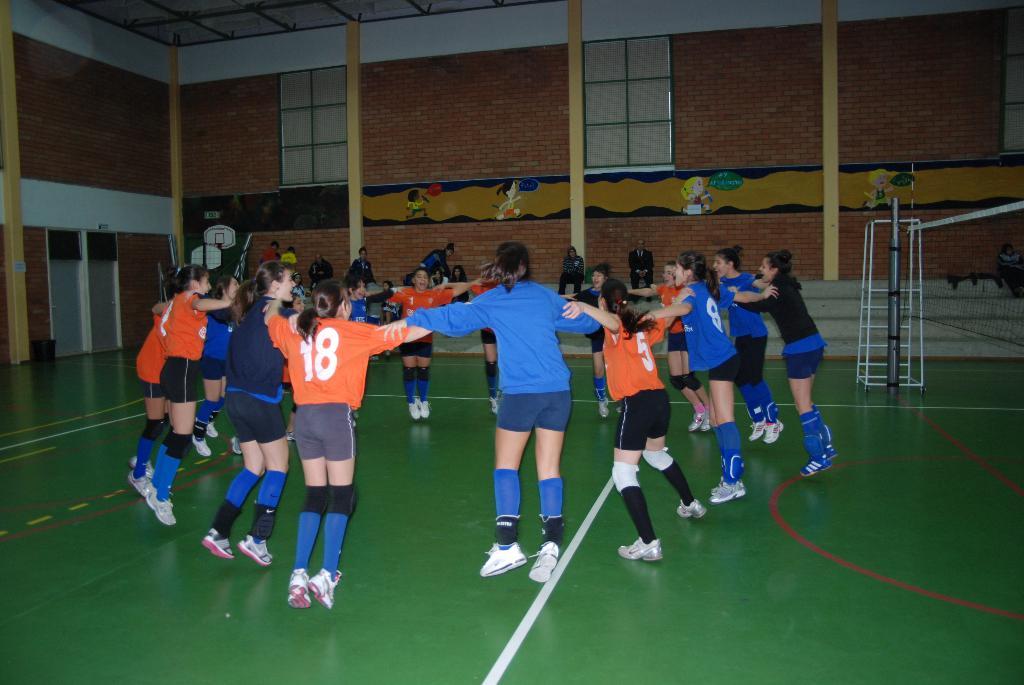What number is on the blue jersey on the right?
Give a very brief answer. 8. What number is the player in the orange jersey on the left?
Your answer should be compact. 18. 